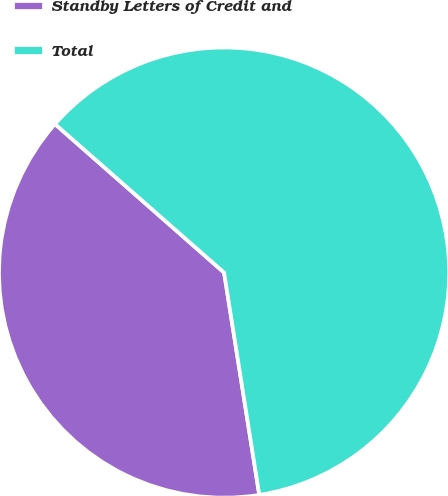Convert chart to OTSL. <chart><loc_0><loc_0><loc_500><loc_500><pie_chart><fcel>Standby Letters of Credit and<fcel>Total<nl><fcel>38.97%<fcel>61.03%<nl></chart> 